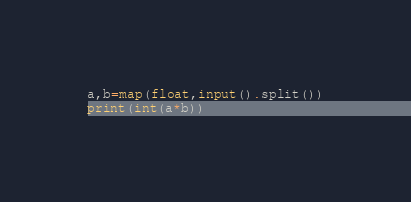Convert code to text. <code><loc_0><loc_0><loc_500><loc_500><_Python_>a,b=map(float,input().split())
print(int(a*b))</code> 